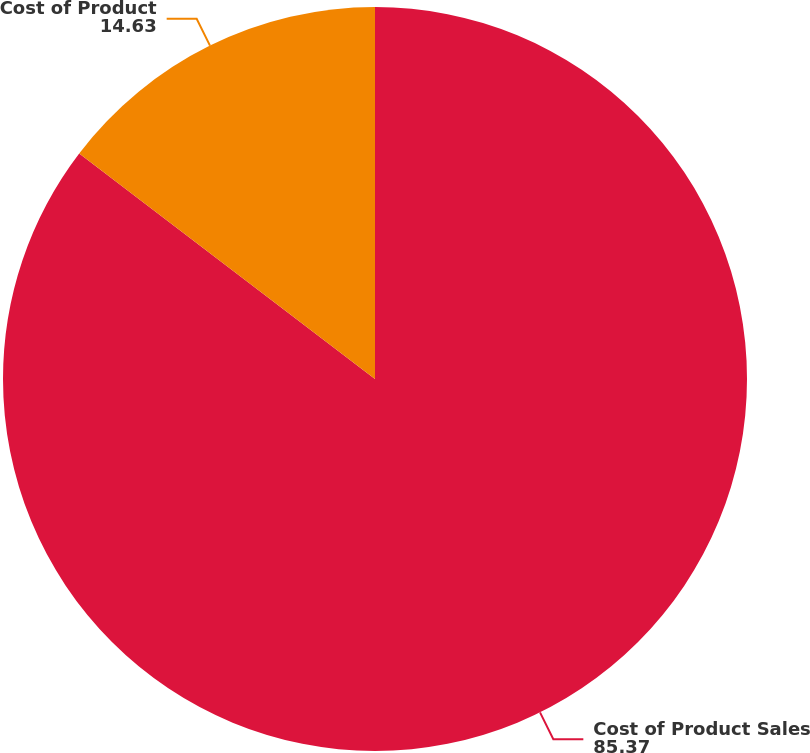Convert chart. <chart><loc_0><loc_0><loc_500><loc_500><pie_chart><fcel>Cost of Product Sales<fcel>Cost of Product<nl><fcel>85.37%<fcel>14.63%<nl></chart> 